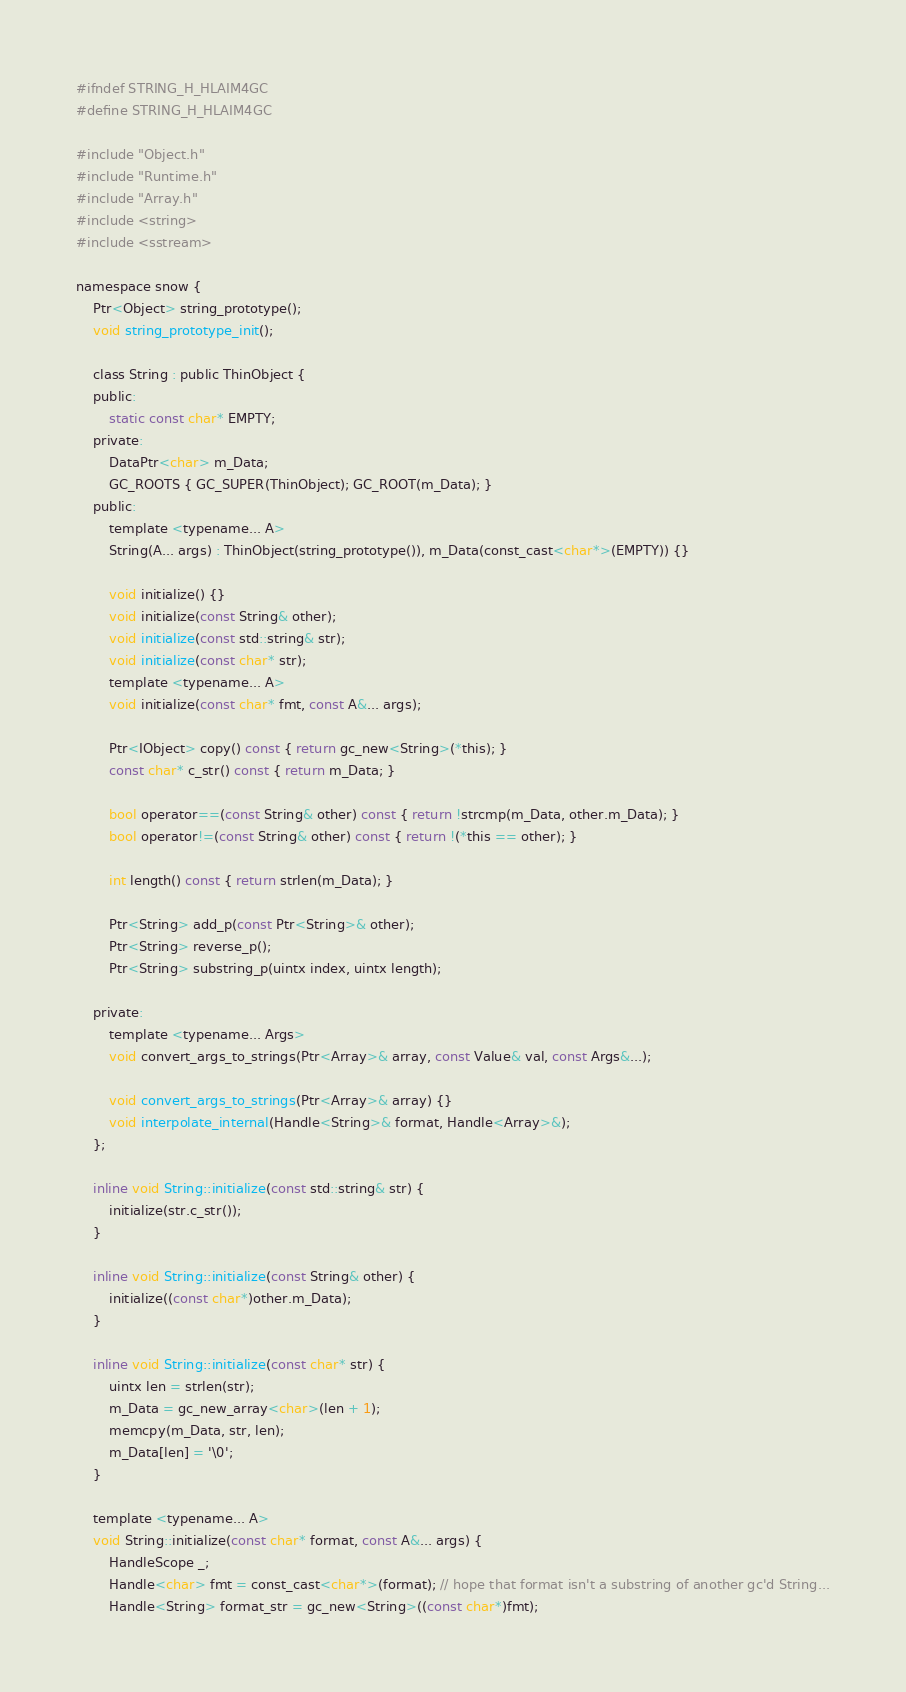Convert code to text. <code><loc_0><loc_0><loc_500><loc_500><_C_>#ifndef STRING_H_HLAIM4GC
#define STRING_H_HLAIM4GC

#include "Object.h"
#include "Runtime.h"
#include "Array.h"
#include <string>
#include <sstream>

namespace snow {
	Ptr<Object> string_prototype();
	void string_prototype_init();
	
	class String : public ThinObject {
	public:
		static const char* EMPTY;
	private:
		DataPtr<char> m_Data;
		GC_ROOTS { GC_SUPER(ThinObject); GC_ROOT(m_Data); }
	public:
		template <typename... A>
		String(A... args) : ThinObject(string_prototype()), m_Data(const_cast<char*>(EMPTY)) {}

		void initialize() {}
		void initialize(const String& other);
		void initialize(const std::string& str);
		void initialize(const char* str);
		template <typename... A>
		void initialize(const char* fmt, const A&... args);

		Ptr<IObject> copy() const { return gc_new<String>(*this); }
		const char* c_str() const { return m_Data; }

		bool operator==(const String& other) const { return !strcmp(m_Data, other.m_Data); }
		bool operator!=(const String& other) const { return !(*this == other); }

		int length() const { return strlen(m_Data); }

		Ptr<String> add_p(const Ptr<String>& other);
		Ptr<String> reverse_p();
		Ptr<String> substring_p(uintx index, uintx length);

	private:
		template <typename... Args>
		void convert_args_to_strings(Ptr<Array>& array, const Value& val, const Args&...);
		
		void convert_args_to_strings(Ptr<Array>& array) {}
		void interpolate_internal(Handle<String>& format, Handle<Array>&); 
	};

	inline void String::initialize(const std::string& str) {
		initialize(str.c_str());
	}

	inline void String::initialize(const String& other) {
		initialize((const char*)other.m_Data);
	}

	inline void String::initialize(const char* str) {
		uintx len = strlen(str);
		m_Data = gc_new_array<char>(len + 1);
		memcpy(m_Data, str, len);
		m_Data[len] = '\0';
	}

	template <typename... A>
	void String::initialize(const char* format, const A&... args) {
		HandleScope _;
		Handle<char> fmt = const_cast<char*>(format); // hope that format isn't a substring of another gc'd String...
		Handle<String> format_str = gc_new<String>((const char*)fmt);</code> 